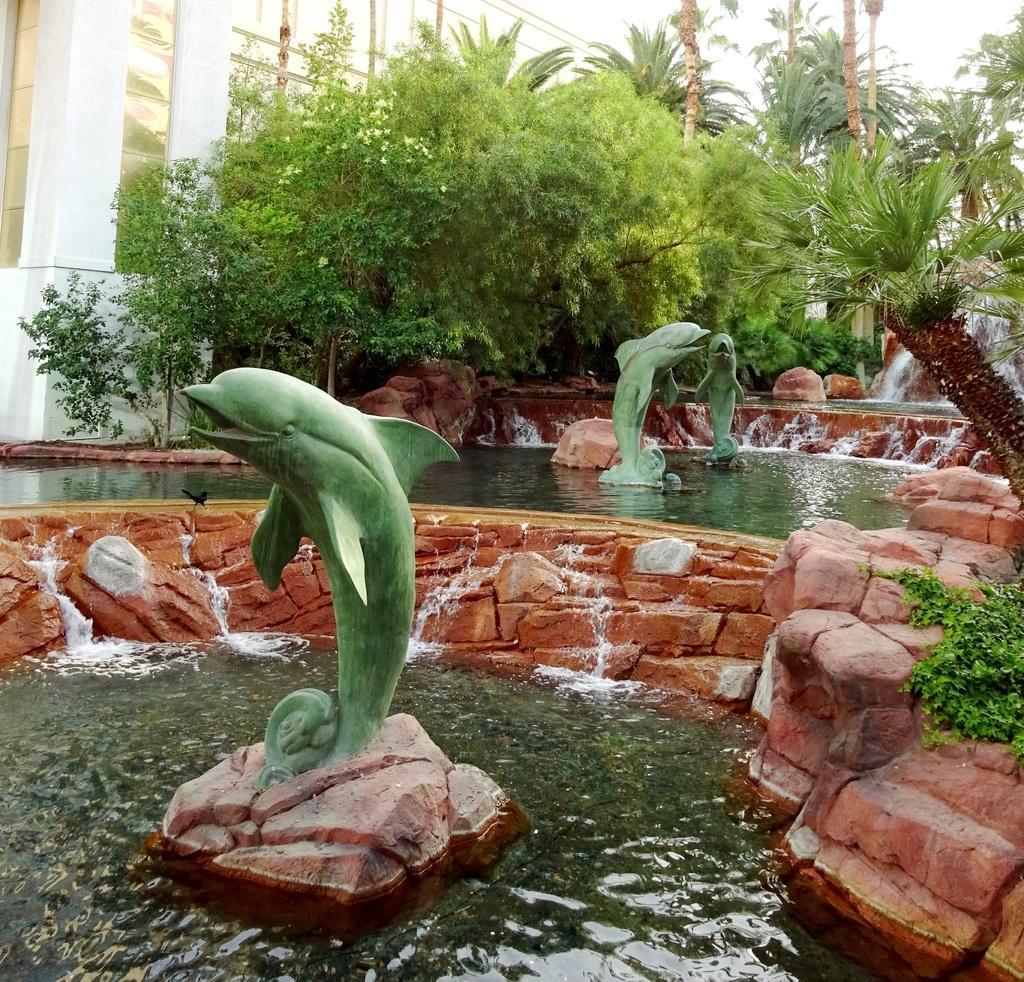How would you summarize this image in a sentence or two? In the foreground of this image, there are dolphin statues in the water. We can also see few stones. In the background, there is water fall and on either side to it, there are trees and plants. At the top, there is a building. 